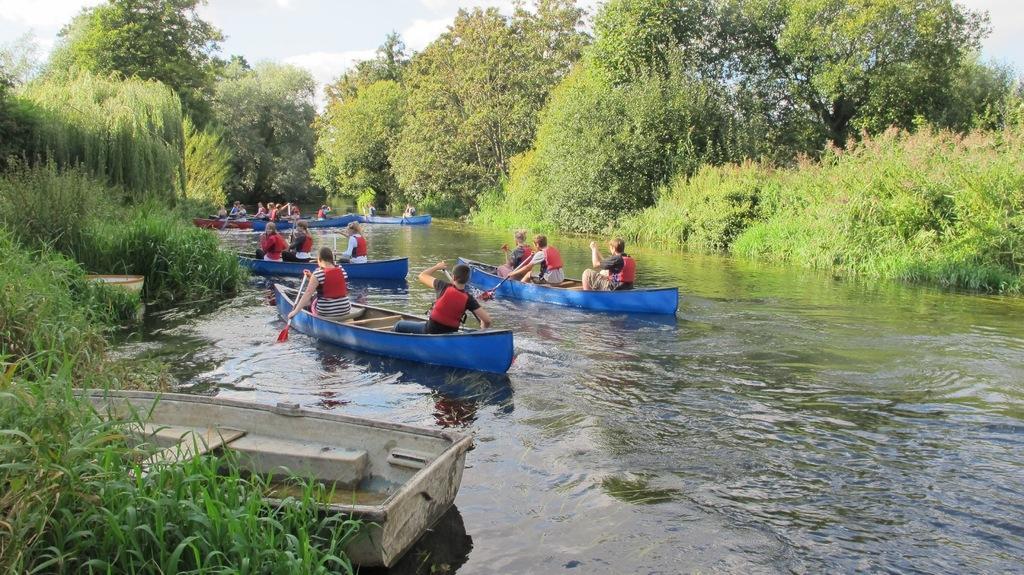Please provide a concise description of this image. In this image we can see few people rowing boats on the water and there are few plants, trees and the sky in the background. 